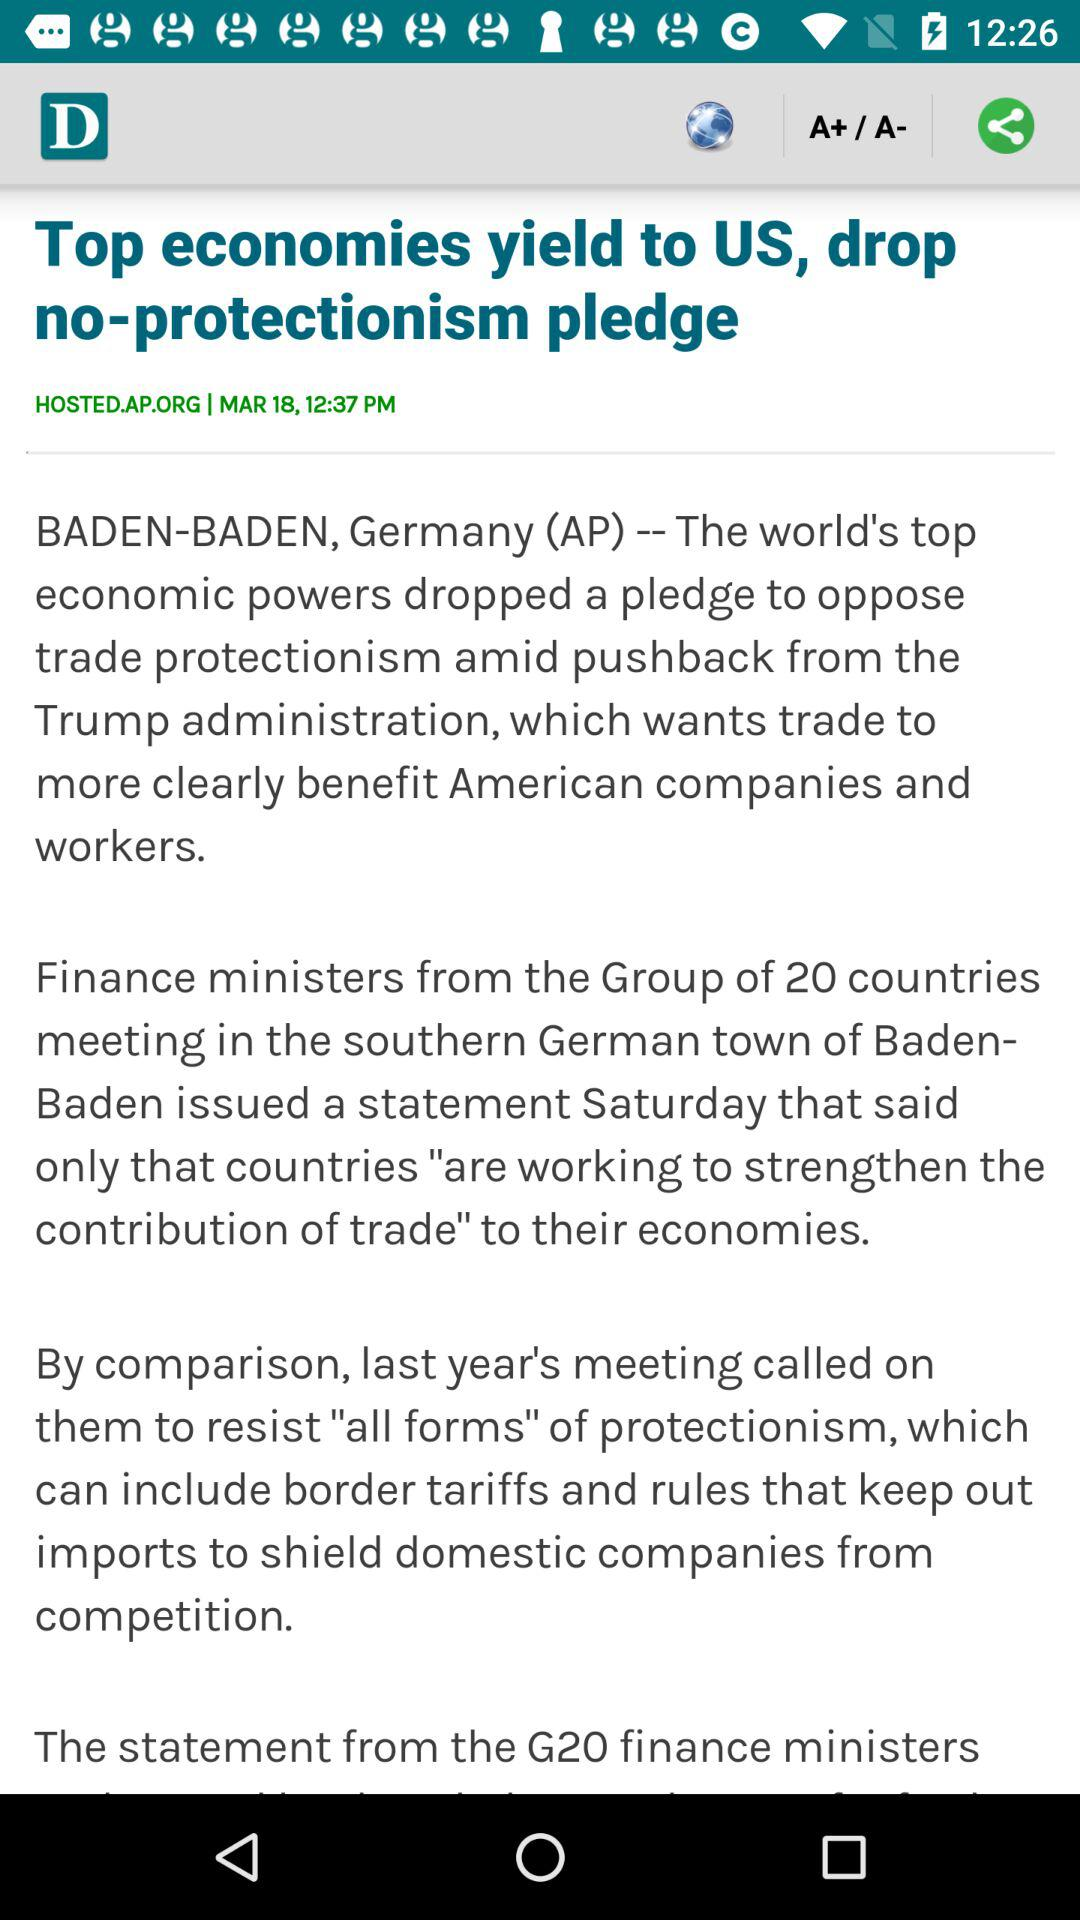What is the headline? The headline is "Top economies yield to US, drop no-protectionism pledge". 